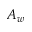<formula> <loc_0><loc_0><loc_500><loc_500>A _ { w }</formula> 